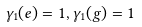<formula> <loc_0><loc_0><loc_500><loc_500>\gamma _ { 1 } ( e ) = 1 , \gamma _ { 1 } ( g ) = 1</formula> 